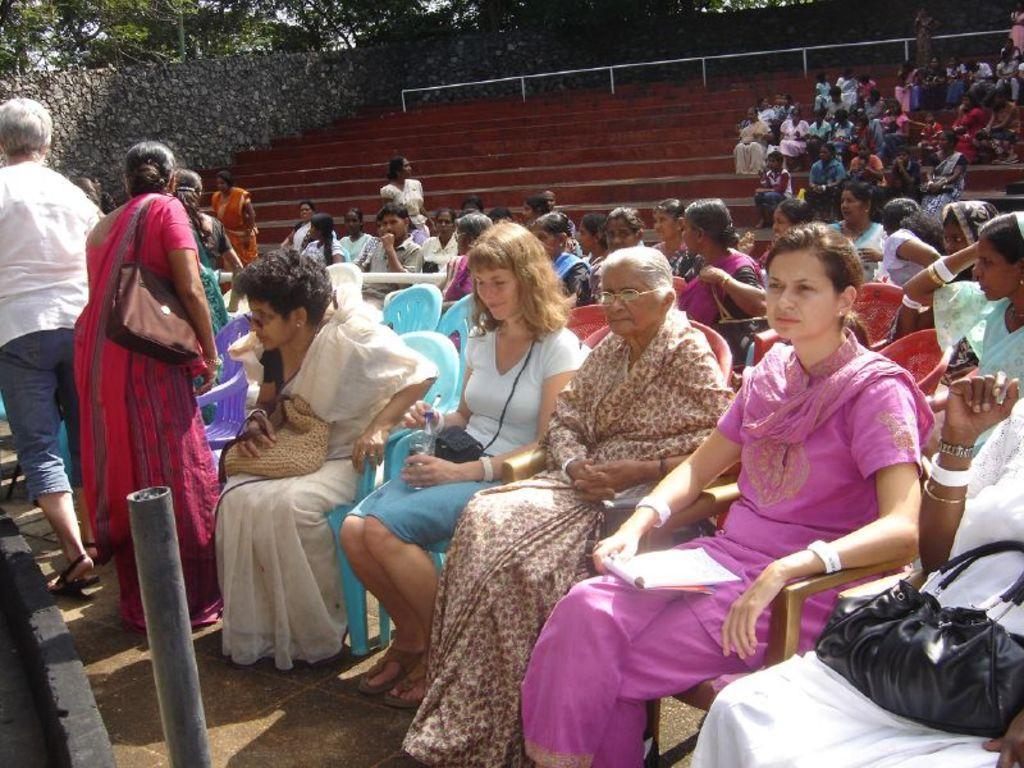How would you summarize this image in a sentence or two? In this image we can see many persons sitting on the chairs. In the background we can see wall and trees. 